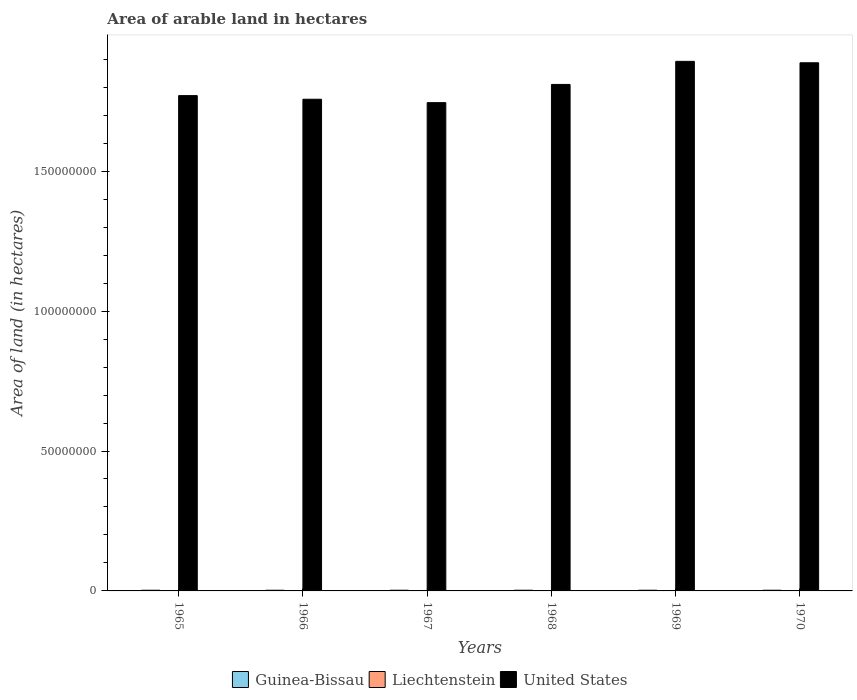How many groups of bars are there?
Provide a short and direct response. 6. Are the number of bars per tick equal to the number of legend labels?
Keep it short and to the point. Yes. How many bars are there on the 3rd tick from the left?
Provide a succinct answer. 3. How many bars are there on the 5th tick from the right?
Provide a succinct answer. 3. What is the label of the 2nd group of bars from the left?
Offer a very short reply. 1966. In how many cases, is the number of bars for a given year not equal to the number of legend labels?
Your answer should be compact. 0. What is the total arable land in United States in 1965?
Offer a very short reply. 1.77e+08. Across all years, what is the maximum total arable land in Liechtenstein?
Provide a succinct answer. 4000. Across all years, what is the minimum total arable land in Guinea-Bissau?
Offer a very short reply. 2.35e+05. In which year was the total arable land in Liechtenstein maximum?
Offer a terse response. 1965. In which year was the total arable land in Guinea-Bissau minimum?
Ensure brevity in your answer.  1965. What is the total total arable land in Guinea-Bissau in the graph?
Your answer should be very brief. 1.45e+06. What is the difference between the total arable land in Liechtenstein in 1966 and that in 1967?
Provide a succinct answer. 0. What is the difference between the total arable land in United States in 1968 and the total arable land in Guinea-Bissau in 1969?
Offer a very short reply. 1.81e+08. What is the average total arable land in Guinea-Bissau per year?
Give a very brief answer. 2.42e+05. In the year 1969, what is the difference between the total arable land in United States and total arable land in Guinea-Bissau?
Provide a short and direct response. 1.89e+08. In how many years, is the total arable land in United States greater than 110000000 hectares?
Provide a succinct answer. 6. What is the ratio of the total arable land in United States in 1965 to that in 1968?
Offer a very short reply. 0.98. What is the difference between the highest and the second highest total arable land in United States?
Ensure brevity in your answer.  5.09e+05. What does the 1st bar from the left in 1966 represents?
Your answer should be very brief. Guinea-Bissau. What does the 3rd bar from the right in 1970 represents?
Offer a very short reply. Guinea-Bissau. How many bars are there?
Give a very brief answer. 18. Does the graph contain any zero values?
Ensure brevity in your answer.  No. How many legend labels are there?
Provide a short and direct response. 3. How are the legend labels stacked?
Keep it short and to the point. Horizontal. What is the title of the graph?
Give a very brief answer. Area of arable land in hectares. What is the label or title of the X-axis?
Your response must be concise. Years. What is the label or title of the Y-axis?
Offer a very short reply. Area of land (in hectares). What is the Area of land (in hectares) of Guinea-Bissau in 1965?
Ensure brevity in your answer.  2.35e+05. What is the Area of land (in hectares) in Liechtenstein in 1965?
Keep it short and to the point. 4000. What is the Area of land (in hectares) of United States in 1965?
Keep it short and to the point. 1.77e+08. What is the Area of land (in hectares) in Guinea-Bissau in 1966?
Make the answer very short. 2.35e+05. What is the Area of land (in hectares) of Liechtenstein in 1966?
Make the answer very short. 4000. What is the Area of land (in hectares) of United States in 1966?
Offer a terse response. 1.76e+08. What is the Area of land (in hectares) of Guinea-Bissau in 1967?
Ensure brevity in your answer.  2.45e+05. What is the Area of land (in hectares) of Liechtenstein in 1967?
Make the answer very short. 4000. What is the Area of land (in hectares) of United States in 1967?
Provide a succinct answer. 1.74e+08. What is the Area of land (in hectares) in Guinea-Bissau in 1968?
Your answer should be compact. 2.45e+05. What is the Area of land (in hectares) of Liechtenstein in 1968?
Your answer should be very brief. 4000. What is the Area of land (in hectares) in United States in 1968?
Make the answer very short. 1.81e+08. What is the Area of land (in hectares) of Guinea-Bissau in 1969?
Your answer should be very brief. 2.45e+05. What is the Area of land (in hectares) in Liechtenstein in 1969?
Your answer should be compact. 4000. What is the Area of land (in hectares) of United States in 1969?
Your answer should be very brief. 1.89e+08. What is the Area of land (in hectares) of Guinea-Bissau in 1970?
Ensure brevity in your answer.  2.45e+05. What is the Area of land (in hectares) of Liechtenstein in 1970?
Keep it short and to the point. 4000. What is the Area of land (in hectares) of United States in 1970?
Make the answer very short. 1.89e+08. Across all years, what is the maximum Area of land (in hectares) of Guinea-Bissau?
Your response must be concise. 2.45e+05. Across all years, what is the maximum Area of land (in hectares) of Liechtenstein?
Your response must be concise. 4000. Across all years, what is the maximum Area of land (in hectares) in United States?
Provide a succinct answer. 1.89e+08. Across all years, what is the minimum Area of land (in hectares) of Guinea-Bissau?
Offer a terse response. 2.35e+05. Across all years, what is the minimum Area of land (in hectares) in Liechtenstein?
Your answer should be very brief. 4000. Across all years, what is the minimum Area of land (in hectares) of United States?
Offer a very short reply. 1.74e+08. What is the total Area of land (in hectares) in Guinea-Bissau in the graph?
Ensure brevity in your answer.  1.45e+06. What is the total Area of land (in hectares) in Liechtenstein in the graph?
Offer a very short reply. 2.40e+04. What is the total Area of land (in hectares) in United States in the graph?
Offer a very short reply. 1.09e+09. What is the difference between the Area of land (in hectares) in Liechtenstein in 1965 and that in 1966?
Your answer should be very brief. 0. What is the difference between the Area of land (in hectares) in United States in 1965 and that in 1966?
Your answer should be compact. 1.30e+06. What is the difference between the Area of land (in hectares) in Guinea-Bissau in 1965 and that in 1967?
Offer a very short reply. -10000. What is the difference between the Area of land (in hectares) in United States in 1965 and that in 1967?
Give a very brief answer. 2.51e+06. What is the difference between the Area of land (in hectares) in Guinea-Bissau in 1965 and that in 1968?
Offer a terse response. -10000. What is the difference between the Area of land (in hectares) of Liechtenstein in 1965 and that in 1969?
Provide a short and direct response. 0. What is the difference between the Area of land (in hectares) of United States in 1965 and that in 1969?
Your answer should be compact. -1.22e+07. What is the difference between the Area of land (in hectares) in Guinea-Bissau in 1965 and that in 1970?
Your response must be concise. -10000. What is the difference between the Area of land (in hectares) in Liechtenstein in 1965 and that in 1970?
Provide a short and direct response. 0. What is the difference between the Area of land (in hectares) of United States in 1965 and that in 1970?
Offer a very short reply. -1.17e+07. What is the difference between the Area of land (in hectares) in Liechtenstein in 1966 and that in 1967?
Give a very brief answer. 0. What is the difference between the Area of land (in hectares) of United States in 1966 and that in 1967?
Provide a succinct answer. 1.22e+06. What is the difference between the Area of land (in hectares) in United States in 1966 and that in 1968?
Ensure brevity in your answer.  -5.30e+06. What is the difference between the Area of land (in hectares) of Liechtenstein in 1966 and that in 1969?
Give a very brief answer. 0. What is the difference between the Area of land (in hectares) of United States in 1966 and that in 1969?
Offer a terse response. -1.35e+07. What is the difference between the Area of land (in hectares) in Guinea-Bissau in 1966 and that in 1970?
Your answer should be compact. -10000. What is the difference between the Area of land (in hectares) in Liechtenstein in 1966 and that in 1970?
Make the answer very short. 0. What is the difference between the Area of land (in hectares) of United States in 1966 and that in 1970?
Your answer should be very brief. -1.30e+07. What is the difference between the Area of land (in hectares) in Guinea-Bissau in 1967 and that in 1968?
Make the answer very short. 0. What is the difference between the Area of land (in hectares) of Liechtenstein in 1967 and that in 1968?
Your answer should be very brief. 0. What is the difference between the Area of land (in hectares) in United States in 1967 and that in 1968?
Your answer should be very brief. -6.51e+06. What is the difference between the Area of land (in hectares) of Guinea-Bissau in 1967 and that in 1969?
Your response must be concise. 0. What is the difference between the Area of land (in hectares) in Liechtenstein in 1967 and that in 1969?
Your answer should be compact. 0. What is the difference between the Area of land (in hectares) of United States in 1967 and that in 1969?
Provide a short and direct response. -1.48e+07. What is the difference between the Area of land (in hectares) in United States in 1967 and that in 1970?
Your response must be concise. -1.42e+07. What is the difference between the Area of land (in hectares) in Liechtenstein in 1968 and that in 1969?
Provide a succinct answer. 0. What is the difference between the Area of land (in hectares) of United States in 1968 and that in 1969?
Give a very brief answer. -8.24e+06. What is the difference between the Area of land (in hectares) of Liechtenstein in 1968 and that in 1970?
Make the answer very short. 0. What is the difference between the Area of land (in hectares) of United States in 1968 and that in 1970?
Provide a succinct answer. -7.74e+06. What is the difference between the Area of land (in hectares) of Guinea-Bissau in 1969 and that in 1970?
Offer a terse response. 0. What is the difference between the Area of land (in hectares) of United States in 1969 and that in 1970?
Provide a short and direct response. 5.09e+05. What is the difference between the Area of land (in hectares) in Guinea-Bissau in 1965 and the Area of land (in hectares) in Liechtenstein in 1966?
Offer a very short reply. 2.31e+05. What is the difference between the Area of land (in hectares) of Guinea-Bissau in 1965 and the Area of land (in hectares) of United States in 1966?
Ensure brevity in your answer.  -1.75e+08. What is the difference between the Area of land (in hectares) in Liechtenstein in 1965 and the Area of land (in hectares) in United States in 1966?
Your answer should be very brief. -1.76e+08. What is the difference between the Area of land (in hectares) of Guinea-Bissau in 1965 and the Area of land (in hectares) of Liechtenstein in 1967?
Keep it short and to the point. 2.31e+05. What is the difference between the Area of land (in hectares) in Guinea-Bissau in 1965 and the Area of land (in hectares) in United States in 1967?
Provide a short and direct response. -1.74e+08. What is the difference between the Area of land (in hectares) of Liechtenstein in 1965 and the Area of land (in hectares) of United States in 1967?
Provide a succinct answer. -1.74e+08. What is the difference between the Area of land (in hectares) in Guinea-Bissau in 1965 and the Area of land (in hectares) in Liechtenstein in 1968?
Provide a succinct answer. 2.31e+05. What is the difference between the Area of land (in hectares) of Guinea-Bissau in 1965 and the Area of land (in hectares) of United States in 1968?
Offer a terse response. -1.81e+08. What is the difference between the Area of land (in hectares) of Liechtenstein in 1965 and the Area of land (in hectares) of United States in 1968?
Your response must be concise. -1.81e+08. What is the difference between the Area of land (in hectares) in Guinea-Bissau in 1965 and the Area of land (in hectares) in Liechtenstein in 1969?
Your answer should be very brief. 2.31e+05. What is the difference between the Area of land (in hectares) in Guinea-Bissau in 1965 and the Area of land (in hectares) in United States in 1969?
Keep it short and to the point. -1.89e+08. What is the difference between the Area of land (in hectares) in Liechtenstein in 1965 and the Area of land (in hectares) in United States in 1969?
Offer a terse response. -1.89e+08. What is the difference between the Area of land (in hectares) in Guinea-Bissau in 1965 and the Area of land (in hectares) in Liechtenstein in 1970?
Make the answer very short. 2.31e+05. What is the difference between the Area of land (in hectares) in Guinea-Bissau in 1965 and the Area of land (in hectares) in United States in 1970?
Keep it short and to the point. -1.88e+08. What is the difference between the Area of land (in hectares) of Liechtenstein in 1965 and the Area of land (in hectares) of United States in 1970?
Provide a short and direct response. -1.89e+08. What is the difference between the Area of land (in hectares) in Guinea-Bissau in 1966 and the Area of land (in hectares) in Liechtenstein in 1967?
Your response must be concise. 2.31e+05. What is the difference between the Area of land (in hectares) in Guinea-Bissau in 1966 and the Area of land (in hectares) in United States in 1967?
Offer a terse response. -1.74e+08. What is the difference between the Area of land (in hectares) in Liechtenstein in 1966 and the Area of land (in hectares) in United States in 1967?
Offer a terse response. -1.74e+08. What is the difference between the Area of land (in hectares) in Guinea-Bissau in 1966 and the Area of land (in hectares) in Liechtenstein in 1968?
Offer a very short reply. 2.31e+05. What is the difference between the Area of land (in hectares) of Guinea-Bissau in 1966 and the Area of land (in hectares) of United States in 1968?
Your response must be concise. -1.81e+08. What is the difference between the Area of land (in hectares) in Liechtenstein in 1966 and the Area of land (in hectares) in United States in 1968?
Provide a succinct answer. -1.81e+08. What is the difference between the Area of land (in hectares) of Guinea-Bissau in 1966 and the Area of land (in hectares) of Liechtenstein in 1969?
Offer a terse response. 2.31e+05. What is the difference between the Area of land (in hectares) of Guinea-Bissau in 1966 and the Area of land (in hectares) of United States in 1969?
Ensure brevity in your answer.  -1.89e+08. What is the difference between the Area of land (in hectares) in Liechtenstein in 1966 and the Area of land (in hectares) in United States in 1969?
Give a very brief answer. -1.89e+08. What is the difference between the Area of land (in hectares) of Guinea-Bissau in 1966 and the Area of land (in hectares) of Liechtenstein in 1970?
Make the answer very short. 2.31e+05. What is the difference between the Area of land (in hectares) in Guinea-Bissau in 1966 and the Area of land (in hectares) in United States in 1970?
Offer a very short reply. -1.88e+08. What is the difference between the Area of land (in hectares) of Liechtenstein in 1966 and the Area of land (in hectares) of United States in 1970?
Give a very brief answer. -1.89e+08. What is the difference between the Area of land (in hectares) of Guinea-Bissau in 1967 and the Area of land (in hectares) of Liechtenstein in 1968?
Make the answer very short. 2.41e+05. What is the difference between the Area of land (in hectares) of Guinea-Bissau in 1967 and the Area of land (in hectares) of United States in 1968?
Offer a very short reply. -1.81e+08. What is the difference between the Area of land (in hectares) of Liechtenstein in 1967 and the Area of land (in hectares) of United States in 1968?
Make the answer very short. -1.81e+08. What is the difference between the Area of land (in hectares) in Guinea-Bissau in 1967 and the Area of land (in hectares) in Liechtenstein in 1969?
Give a very brief answer. 2.41e+05. What is the difference between the Area of land (in hectares) in Guinea-Bissau in 1967 and the Area of land (in hectares) in United States in 1969?
Offer a very short reply. -1.89e+08. What is the difference between the Area of land (in hectares) of Liechtenstein in 1967 and the Area of land (in hectares) of United States in 1969?
Offer a terse response. -1.89e+08. What is the difference between the Area of land (in hectares) of Guinea-Bissau in 1967 and the Area of land (in hectares) of Liechtenstein in 1970?
Your answer should be very brief. 2.41e+05. What is the difference between the Area of land (in hectares) in Guinea-Bissau in 1967 and the Area of land (in hectares) in United States in 1970?
Your answer should be very brief. -1.88e+08. What is the difference between the Area of land (in hectares) in Liechtenstein in 1967 and the Area of land (in hectares) in United States in 1970?
Ensure brevity in your answer.  -1.89e+08. What is the difference between the Area of land (in hectares) in Guinea-Bissau in 1968 and the Area of land (in hectares) in Liechtenstein in 1969?
Offer a terse response. 2.41e+05. What is the difference between the Area of land (in hectares) of Guinea-Bissau in 1968 and the Area of land (in hectares) of United States in 1969?
Provide a short and direct response. -1.89e+08. What is the difference between the Area of land (in hectares) in Liechtenstein in 1968 and the Area of land (in hectares) in United States in 1969?
Give a very brief answer. -1.89e+08. What is the difference between the Area of land (in hectares) in Guinea-Bissau in 1968 and the Area of land (in hectares) in Liechtenstein in 1970?
Give a very brief answer. 2.41e+05. What is the difference between the Area of land (in hectares) of Guinea-Bissau in 1968 and the Area of land (in hectares) of United States in 1970?
Make the answer very short. -1.88e+08. What is the difference between the Area of land (in hectares) in Liechtenstein in 1968 and the Area of land (in hectares) in United States in 1970?
Ensure brevity in your answer.  -1.89e+08. What is the difference between the Area of land (in hectares) in Guinea-Bissau in 1969 and the Area of land (in hectares) in Liechtenstein in 1970?
Your answer should be very brief. 2.41e+05. What is the difference between the Area of land (in hectares) in Guinea-Bissau in 1969 and the Area of land (in hectares) in United States in 1970?
Ensure brevity in your answer.  -1.88e+08. What is the difference between the Area of land (in hectares) of Liechtenstein in 1969 and the Area of land (in hectares) of United States in 1970?
Ensure brevity in your answer.  -1.89e+08. What is the average Area of land (in hectares) of Guinea-Bissau per year?
Make the answer very short. 2.42e+05. What is the average Area of land (in hectares) of Liechtenstein per year?
Offer a terse response. 4000. What is the average Area of land (in hectares) of United States per year?
Offer a very short reply. 1.81e+08. In the year 1965, what is the difference between the Area of land (in hectares) of Guinea-Bissau and Area of land (in hectares) of Liechtenstein?
Keep it short and to the point. 2.31e+05. In the year 1965, what is the difference between the Area of land (in hectares) in Guinea-Bissau and Area of land (in hectares) in United States?
Provide a succinct answer. -1.77e+08. In the year 1965, what is the difference between the Area of land (in hectares) of Liechtenstein and Area of land (in hectares) of United States?
Give a very brief answer. -1.77e+08. In the year 1966, what is the difference between the Area of land (in hectares) of Guinea-Bissau and Area of land (in hectares) of Liechtenstein?
Provide a short and direct response. 2.31e+05. In the year 1966, what is the difference between the Area of land (in hectares) in Guinea-Bissau and Area of land (in hectares) in United States?
Give a very brief answer. -1.75e+08. In the year 1966, what is the difference between the Area of land (in hectares) of Liechtenstein and Area of land (in hectares) of United States?
Your answer should be very brief. -1.76e+08. In the year 1967, what is the difference between the Area of land (in hectares) in Guinea-Bissau and Area of land (in hectares) in Liechtenstein?
Ensure brevity in your answer.  2.41e+05. In the year 1967, what is the difference between the Area of land (in hectares) of Guinea-Bissau and Area of land (in hectares) of United States?
Offer a very short reply. -1.74e+08. In the year 1967, what is the difference between the Area of land (in hectares) in Liechtenstein and Area of land (in hectares) in United States?
Your response must be concise. -1.74e+08. In the year 1968, what is the difference between the Area of land (in hectares) in Guinea-Bissau and Area of land (in hectares) in Liechtenstein?
Your answer should be compact. 2.41e+05. In the year 1968, what is the difference between the Area of land (in hectares) of Guinea-Bissau and Area of land (in hectares) of United States?
Provide a succinct answer. -1.81e+08. In the year 1968, what is the difference between the Area of land (in hectares) of Liechtenstein and Area of land (in hectares) of United States?
Ensure brevity in your answer.  -1.81e+08. In the year 1969, what is the difference between the Area of land (in hectares) in Guinea-Bissau and Area of land (in hectares) in Liechtenstein?
Provide a short and direct response. 2.41e+05. In the year 1969, what is the difference between the Area of land (in hectares) of Guinea-Bissau and Area of land (in hectares) of United States?
Ensure brevity in your answer.  -1.89e+08. In the year 1969, what is the difference between the Area of land (in hectares) of Liechtenstein and Area of land (in hectares) of United States?
Provide a succinct answer. -1.89e+08. In the year 1970, what is the difference between the Area of land (in hectares) in Guinea-Bissau and Area of land (in hectares) in Liechtenstein?
Your response must be concise. 2.41e+05. In the year 1970, what is the difference between the Area of land (in hectares) in Guinea-Bissau and Area of land (in hectares) in United States?
Keep it short and to the point. -1.88e+08. In the year 1970, what is the difference between the Area of land (in hectares) of Liechtenstein and Area of land (in hectares) of United States?
Your response must be concise. -1.89e+08. What is the ratio of the Area of land (in hectares) in Liechtenstein in 1965 to that in 1966?
Make the answer very short. 1. What is the ratio of the Area of land (in hectares) of United States in 1965 to that in 1966?
Offer a very short reply. 1.01. What is the ratio of the Area of land (in hectares) of Guinea-Bissau in 1965 to that in 1967?
Offer a very short reply. 0.96. What is the ratio of the Area of land (in hectares) in Liechtenstein in 1965 to that in 1967?
Ensure brevity in your answer.  1. What is the ratio of the Area of land (in hectares) in United States in 1965 to that in 1967?
Keep it short and to the point. 1.01. What is the ratio of the Area of land (in hectares) in Guinea-Bissau in 1965 to that in 1968?
Provide a short and direct response. 0.96. What is the ratio of the Area of land (in hectares) in United States in 1965 to that in 1968?
Provide a short and direct response. 0.98. What is the ratio of the Area of land (in hectares) of Guinea-Bissau in 1965 to that in 1969?
Keep it short and to the point. 0.96. What is the ratio of the Area of land (in hectares) in Liechtenstein in 1965 to that in 1969?
Keep it short and to the point. 1. What is the ratio of the Area of land (in hectares) of United States in 1965 to that in 1969?
Give a very brief answer. 0.94. What is the ratio of the Area of land (in hectares) in Guinea-Bissau in 1965 to that in 1970?
Offer a very short reply. 0.96. What is the ratio of the Area of land (in hectares) in United States in 1965 to that in 1970?
Your answer should be compact. 0.94. What is the ratio of the Area of land (in hectares) of Guinea-Bissau in 1966 to that in 1967?
Give a very brief answer. 0.96. What is the ratio of the Area of land (in hectares) in Liechtenstein in 1966 to that in 1967?
Your answer should be compact. 1. What is the ratio of the Area of land (in hectares) in United States in 1966 to that in 1967?
Make the answer very short. 1.01. What is the ratio of the Area of land (in hectares) in Guinea-Bissau in 1966 to that in 1968?
Keep it short and to the point. 0.96. What is the ratio of the Area of land (in hectares) in Liechtenstein in 1966 to that in 1968?
Ensure brevity in your answer.  1. What is the ratio of the Area of land (in hectares) in United States in 1966 to that in 1968?
Provide a succinct answer. 0.97. What is the ratio of the Area of land (in hectares) in Guinea-Bissau in 1966 to that in 1969?
Make the answer very short. 0.96. What is the ratio of the Area of land (in hectares) of United States in 1966 to that in 1969?
Make the answer very short. 0.93. What is the ratio of the Area of land (in hectares) in Guinea-Bissau in 1966 to that in 1970?
Give a very brief answer. 0.96. What is the ratio of the Area of land (in hectares) in Liechtenstein in 1966 to that in 1970?
Your answer should be very brief. 1. What is the ratio of the Area of land (in hectares) in Liechtenstein in 1967 to that in 1968?
Give a very brief answer. 1. What is the ratio of the Area of land (in hectares) of United States in 1967 to that in 1968?
Make the answer very short. 0.96. What is the ratio of the Area of land (in hectares) of United States in 1967 to that in 1969?
Provide a succinct answer. 0.92. What is the ratio of the Area of land (in hectares) of Guinea-Bissau in 1967 to that in 1970?
Offer a very short reply. 1. What is the ratio of the Area of land (in hectares) in Liechtenstein in 1967 to that in 1970?
Make the answer very short. 1. What is the ratio of the Area of land (in hectares) in United States in 1967 to that in 1970?
Your response must be concise. 0.92. What is the ratio of the Area of land (in hectares) of Liechtenstein in 1968 to that in 1969?
Provide a short and direct response. 1. What is the ratio of the Area of land (in hectares) in United States in 1968 to that in 1969?
Your answer should be very brief. 0.96. What is the ratio of the Area of land (in hectares) of Guinea-Bissau in 1968 to that in 1970?
Provide a short and direct response. 1. What is the ratio of the Area of land (in hectares) of United States in 1968 to that in 1970?
Keep it short and to the point. 0.96. What is the ratio of the Area of land (in hectares) in Guinea-Bissau in 1969 to that in 1970?
Offer a very short reply. 1. What is the ratio of the Area of land (in hectares) in Liechtenstein in 1969 to that in 1970?
Your answer should be compact. 1. What is the ratio of the Area of land (in hectares) of United States in 1969 to that in 1970?
Your answer should be compact. 1. What is the difference between the highest and the second highest Area of land (in hectares) in Guinea-Bissau?
Provide a short and direct response. 0. What is the difference between the highest and the second highest Area of land (in hectares) of United States?
Provide a succinct answer. 5.09e+05. What is the difference between the highest and the lowest Area of land (in hectares) of Liechtenstein?
Make the answer very short. 0. What is the difference between the highest and the lowest Area of land (in hectares) of United States?
Give a very brief answer. 1.48e+07. 